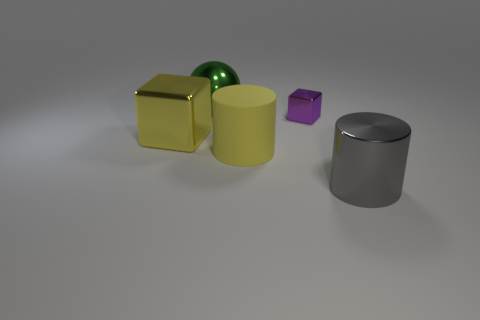Add 5 large brown matte objects. How many objects exist? 10 Subtract all cylinders. How many objects are left? 3 Subtract 1 gray cylinders. How many objects are left? 4 Subtract all small gray metallic cubes. Subtract all big rubber objects. How many objects are left? 4 Add 5 big yellow blocks. How many big yellow blocks are left? 6 Add 2 big red metal blocks. How many big red metal blocks exist? 2 